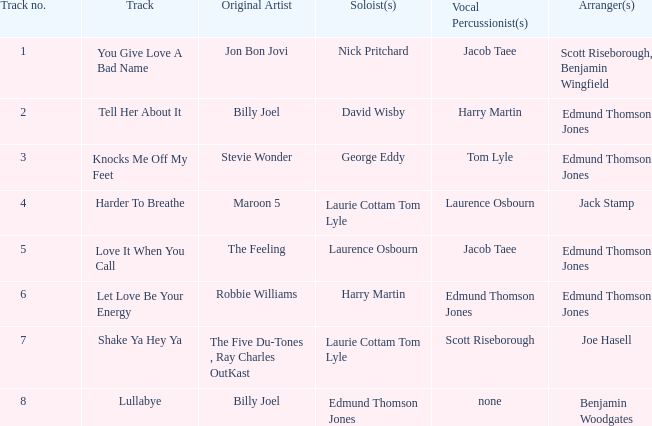Who organized song(s) with tom lyle on the vocal percussion? Edmund Thomson Jones. 